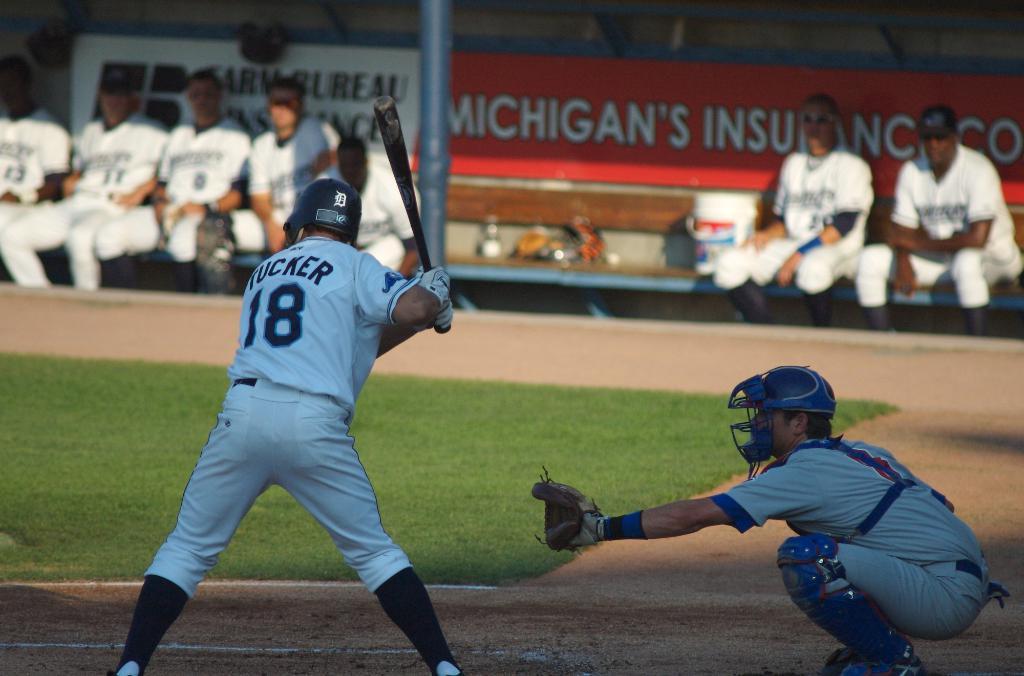What is the player's name holding the bat?
Ensure brevity in your answer.  Tucker. 